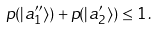Convert formula to latex. <formula><loc_0><loc_0><loc_500><loc_500>p ( | a ^ { \prime \prime } _ { 1 } \rangle ) + p ( | a ^ { \prime } _ { 2 } \rangle ) \leq 1 \, .</formula> 